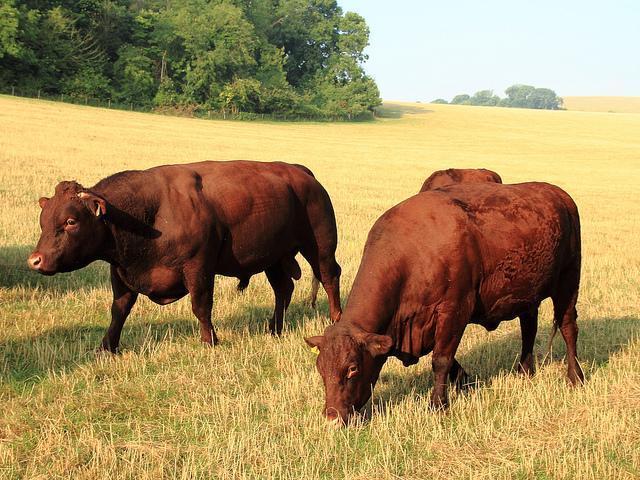How many cows can be seen?
Give a very brief answer. 2. 